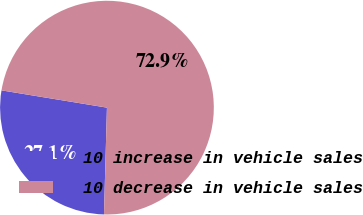Convert chart. <chart><loc_0><loc_0><loc_500><loc_500><pie_chart><fcel>10 increase in vehicle sales<fcel>10 decrease in vehicle sales<nl><fcel>27.14%<fcel>72.86%<nl></chart> 